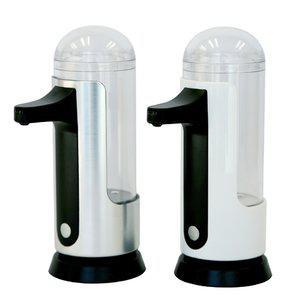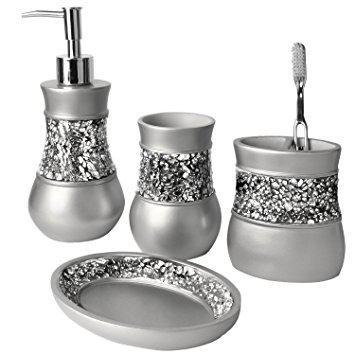The first image is the image on the left, the second image is the image on the right. Given the left and right images, does the statement "An image shows a grouping of four coordinating vanity pieces, with a pump dispenser on the far left." hold true? Answer yes or no. Yes. The first image is the image on the left, the second image is the image on the right. Considering the images on both sides, is "None of the objects are brown in color" valid? Answer yes or no. Yes. 